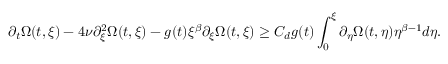<formula> <loc_0><loc_0><loc_500><loc_500>\partial _ { t } \Omega ( t , \xi ) - 4 \nu \partial _ { \xi } ^ { 2 } \Omega ( t , \xi ) - g ( t ) \xi ^ { \beta } \partial _ { \xi } \Omega ( t , \xi ) \geq C _ { d } g ( t ) \int _ { 0 } ^ { \xi } \partial _ { \eta } \Omega ( t , \eta ) \eta ^ { \beta - 1 } d \eta .</formula> 